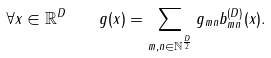<formula> <loc_0><loc_0><loc_500><loc_500>\forall x \in \mathbb { R } ^ { D } \quad g ( x ) = \sum _ { m , n \in \mathbb { N } ^ { \frac { D } { 2 } } } g _ { m n } b _ { m n } ^ { ( D ) } ( x ) .</formula> 